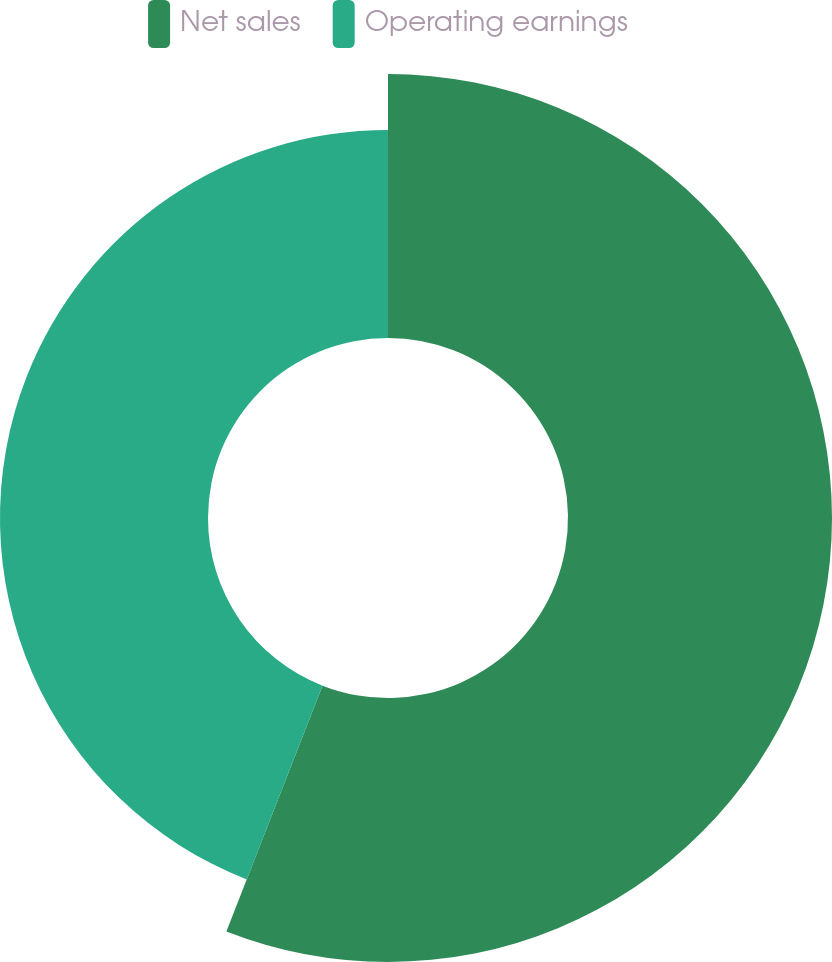<chart> <loc_0><loc_0><loc_500><loc_500><pie_chart><fcel>Net sales<fcel>Operating earnings<nl><fcel>55.93%<fcel>44.07%<nl></chart> 